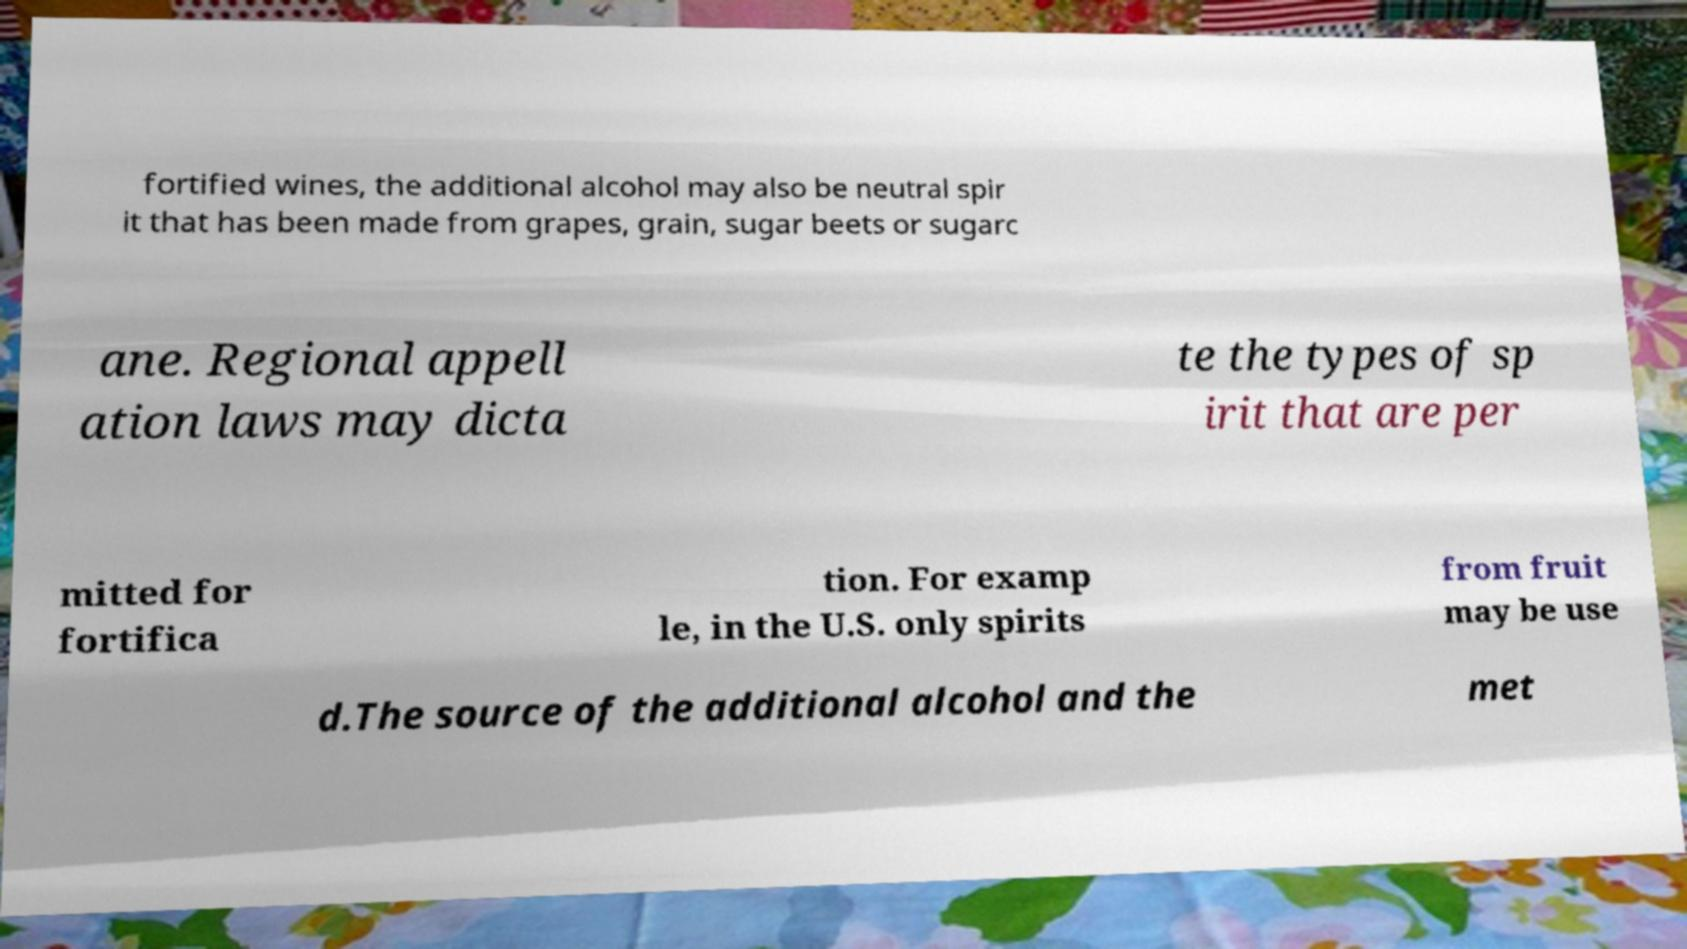Please read and relay the text visible in this image. What does it say? fortified wines, the additional alcohol may also be neutral spir it that has been made from grapes, grain, sugar beets or sugarc ane. Regional appell ation laws may dicta te the types of sp irit that are per mitted for fortifica tion. For examp le, in the U.S. only spirits from fruit may be use d.The source of the additional alcohol and the met 